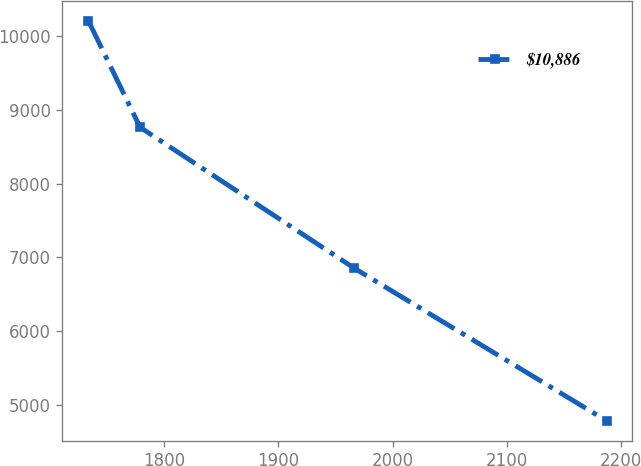<chart> <loc_0><loc_0><loc_500><loc_500><line_chart><ecel><fcel>$10,886<nl><fcel>1733.72<fcel>10213.3<nl><fcel>1779.05<fcel>8763.63<nl><fcel>1966.46<fcel>6849.74<nl><fcel>2187.06<fcel>4779.12<nl></chart> 